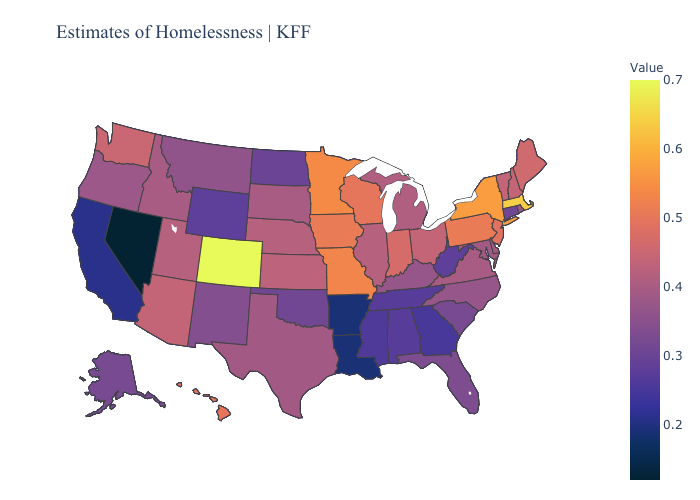Does Hawaii have a higher value than New York?
Keep it brief. No. Does California have a lower value than Nevada?
Give a very brief answer. No. Is the legend a continuous bar?
Write a very short answer. Yes. Which states have the highest value in the USA?
Short answer required. Colorado. Among the states that border Alabama , which have the lowest value?
Be succinct. Georgia. 